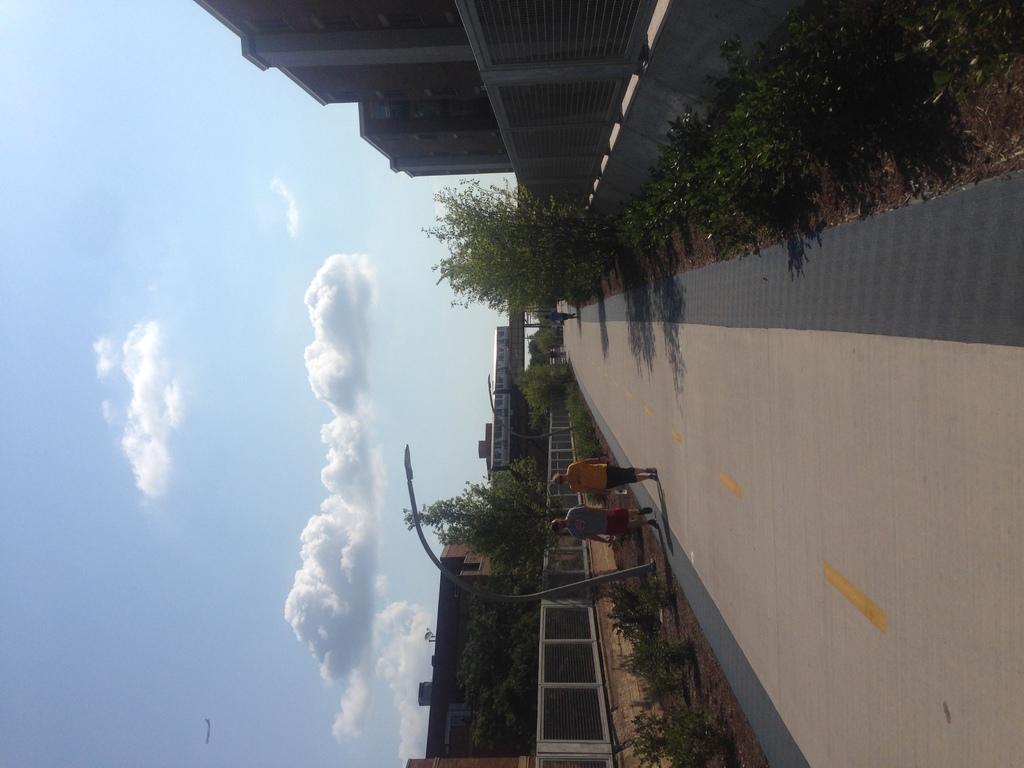In one or two sentences, can you explain what this image depicts? In this picture I can observe a path. There are two members walking in this path. On either sides of this path there are some plants. I can observe a pole. There is a railing. In the background there is a bridge on which a train is moving. I can observe some buildings in this picture. In the background there is a sky with some clouds. 